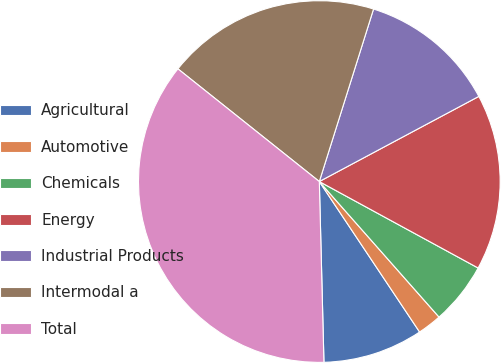Convert chart. <chart><loc_0><loc_0><loc_500><loc_500><pie_chart><fcel>Agricultural<fcel>Automotive<fcel>Chemicals<fcel>Energy<fcel>Industrial Products<fcel>Intermodal a<fcel>Total<nl><fcel>8.95%<fcel>2.16%<fcel>5.55%<fcel>15.74%<fcel>12.35%<fcel>19.14%<fcel>36.12%<nl></chart> 